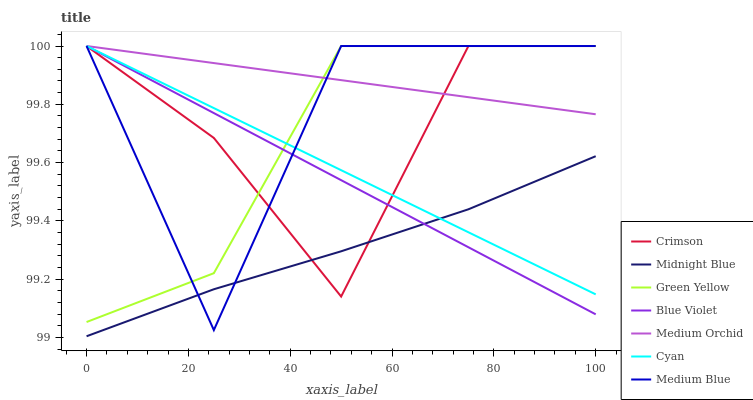Does Midnight Blue have the minimum area under the curve?
Answer yes or no. Yes. Does Medium Orchid have the maximum area under the curve?
Answer yes or no. Yes. Does Medium Blue have the minimum area under the curve?
Answer yes or no. No. Does Medium Blue have the maximum area under the curve?
Answer yes or no. No. Is Blue Violet the smoothest?
Answer yes or no. Yes. Is Medium Blue the roughest?
Answer yes or no. Yes. Is Medium Orchid the smoothest?
Answer yes or no. No. Is Medium Orchid the roughest?
Answer yes or no. No. Does Midnight Blue have the lowest value?
Answer yes or no. Yes. Does Medium Blue have the lowest value?
Answer yes or no. No. Does Blue Violet have the highest value?
Answer yes or no. Yes. Is Midnight Blue less than Medium Orchid?
Answer yes or no. Yes. Is Green Yellow greater than Midnight Blue?
Answer yes or no. Yes. Does Cyan intersect Blue Violet?
Answer yes or no. Yes. Is Cyan less than Blue Violet?
Answer yes or no. No. Is Cyan greater than Blue Violet?
Answer yes or no. No. Does Midnight Blue intersect Medium Orchid?
Answer yes or no. No. 